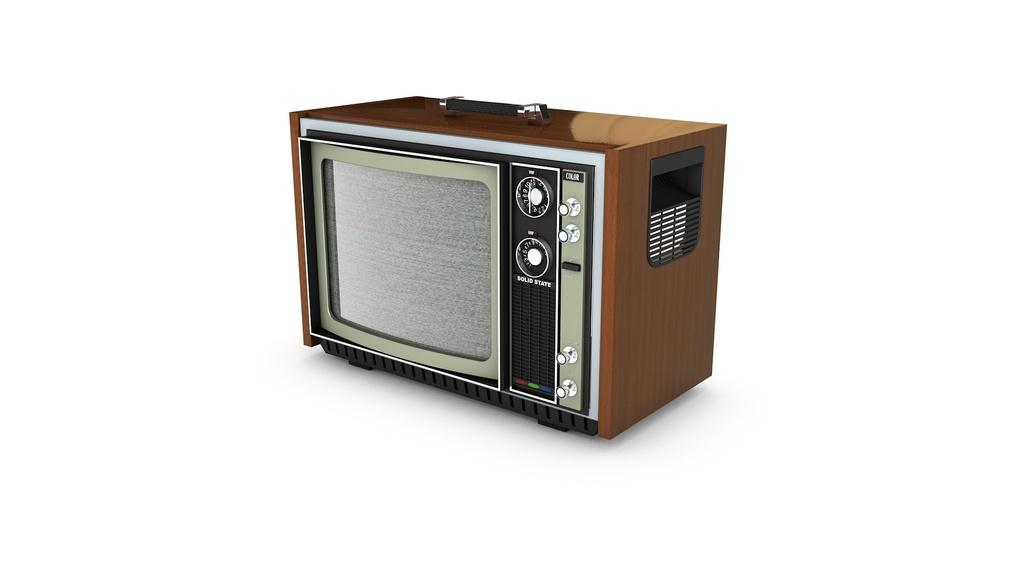What type of electronic device is present in the image? There is an old TV in the image. What type of weather can be seen in the image? There is no weather depicted in the image, as it only features an old TV. Is there a scarecrow present in the image? No, there is no scarecrow present in the image; it only features an old TV. 